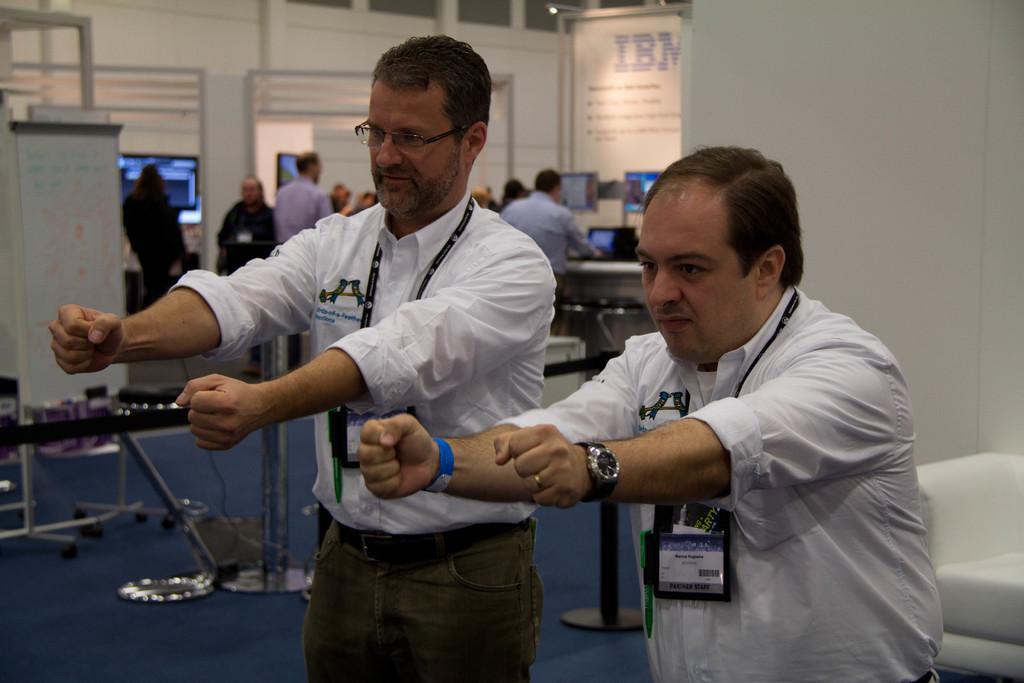In one or two sentences, can you explain what this image depicts? In this image there are many people standing. In the foreground there are two men standing. They are wearing identity cards. They are stretching their hands forward. Behind them there are tables. There are screens on the tables. In the background there is a wall. There is text on the wall. 